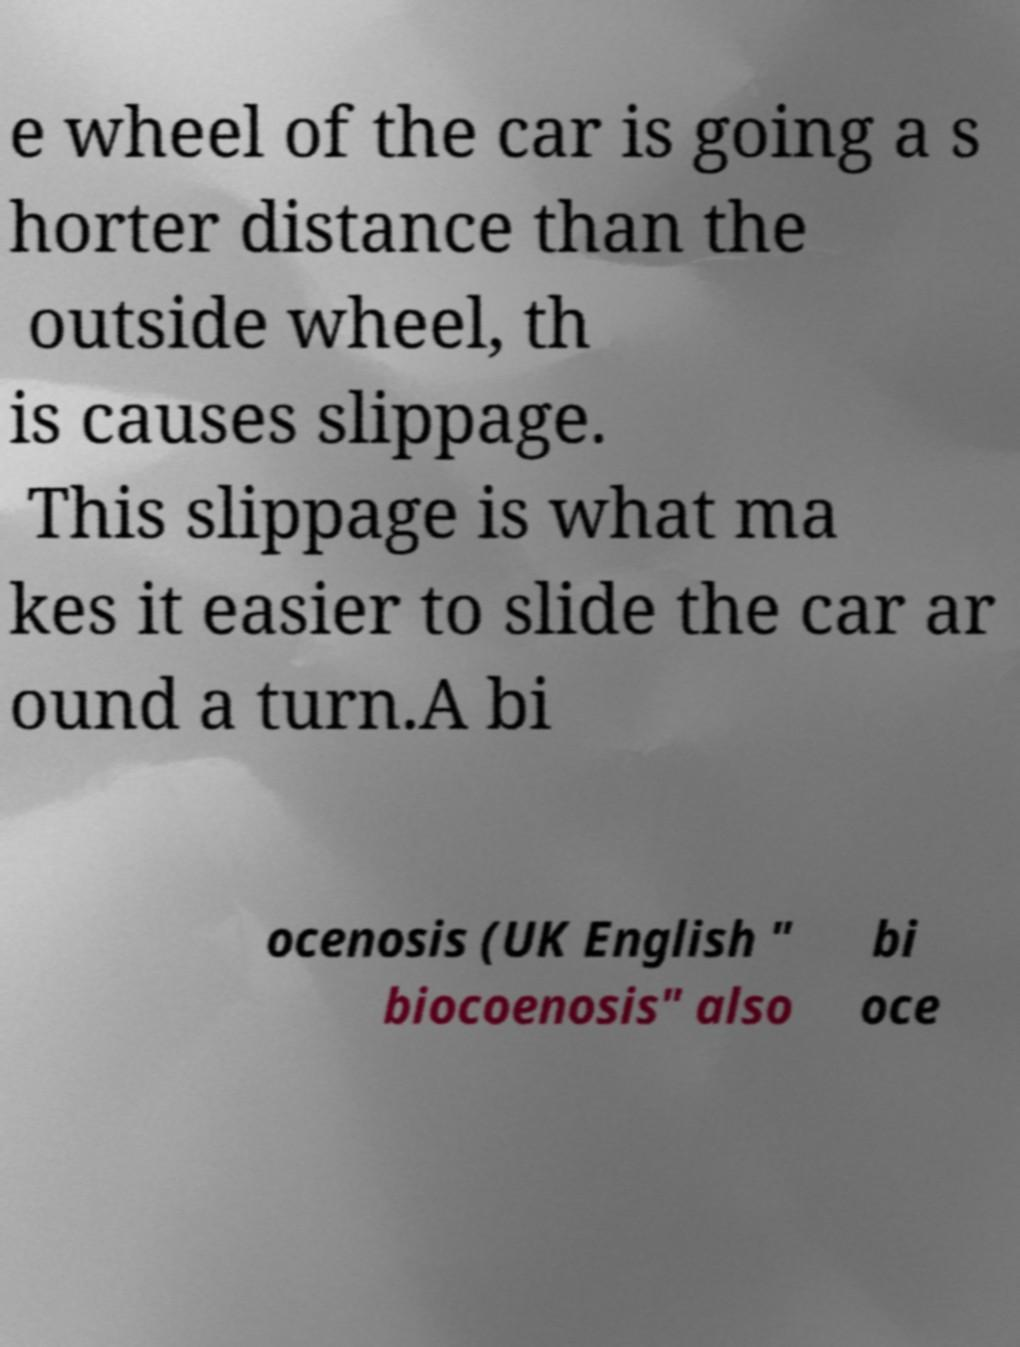Can you accurately transcribe the text from the provided image for me? e wheel of the car is going a s horter distance than the outside wheel, th is causes slippage. This slippage is what ma kes it easier to slide the car ar ound a turn.A bi ocenosis (UK English " biocoenosis" also bi oce 